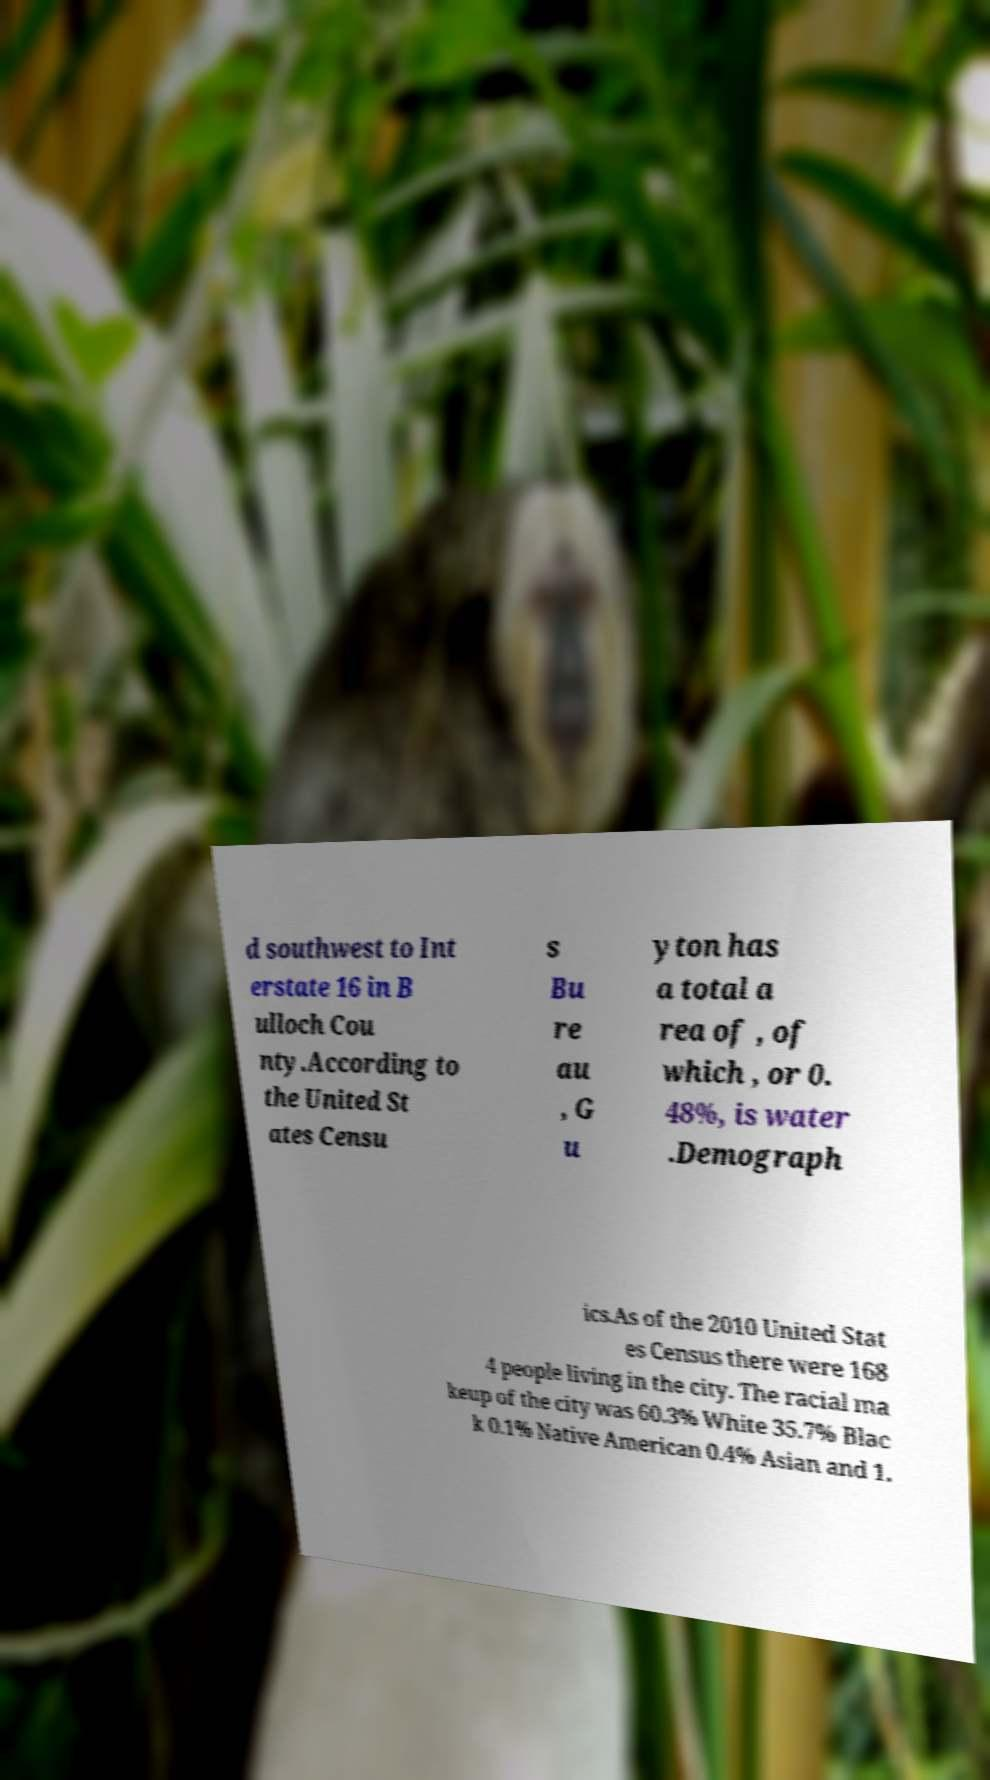Please identify and transcribe the text found in this image. d southwest to Int erstate 16 in B ulloch Cou nty.According to the United St ates Censu s Bu re au , G u yton has a total a rea of , of which , or 0. 48%, is water .Demograph ics.As of the 2010 United Stat es Census there were 168 4 people living in the city. The racial ma keup of the city was 60.3% White 35.7% Blac k 0.1% Native American 0.4% Asian and 1. 